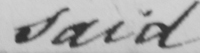What does this handwritten line say? said 